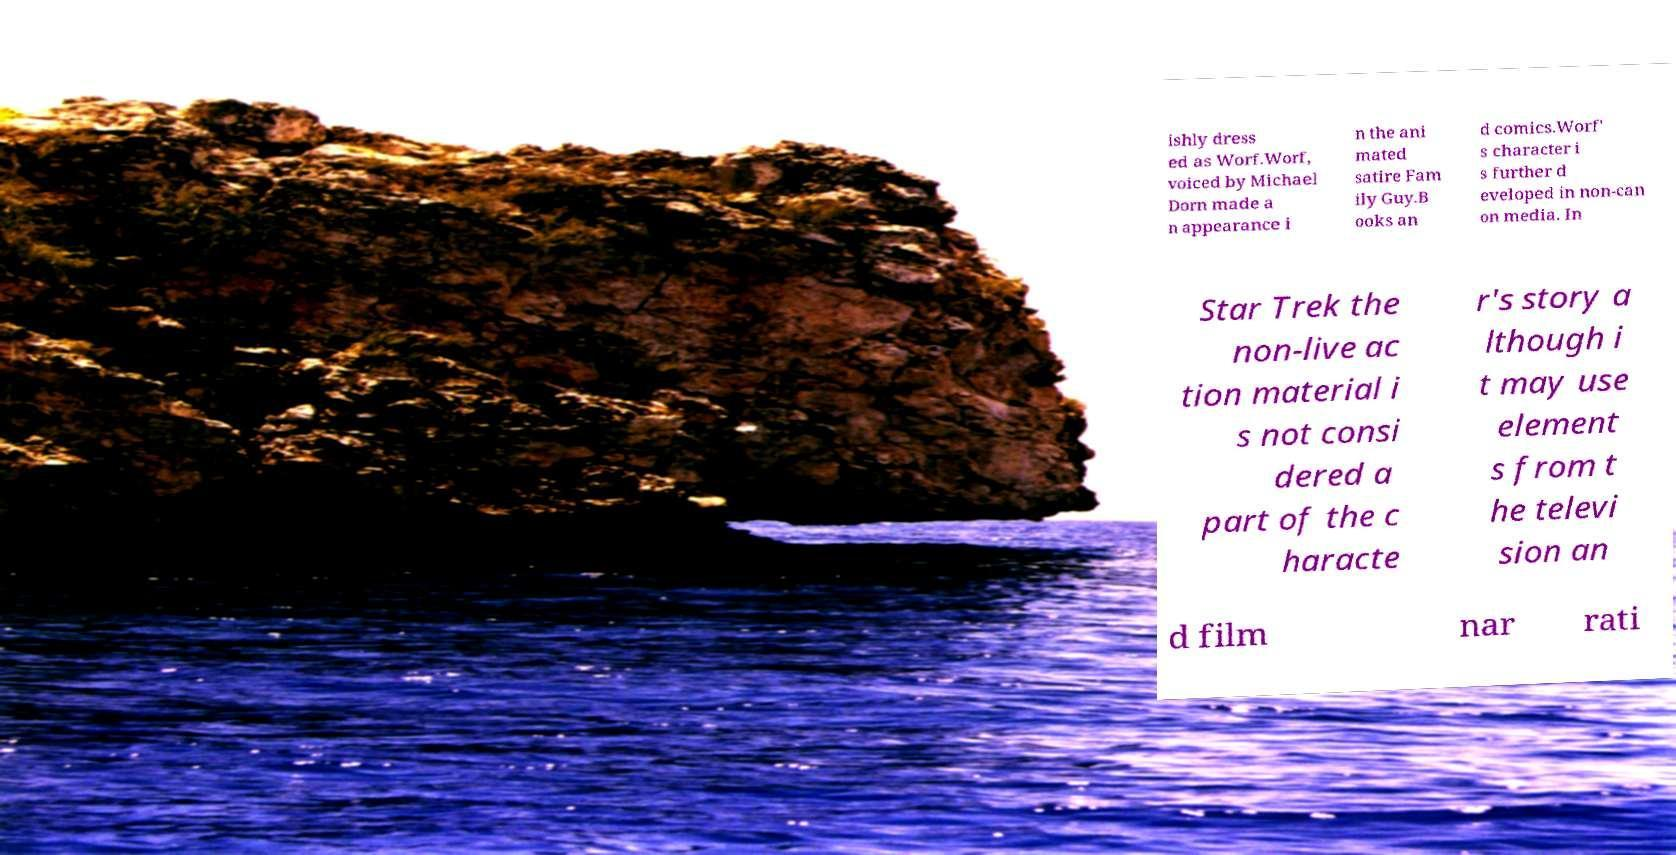Please identify and transcribe the text found in this image. ishly dress ed as Worf.Worf, voiced by Michael Dorn made a n appearance i n the ani mated satire Fam ily Guy.B ooks an d comics.Worf' s character i s further d eveloped in non-can on media. In Star Trek the non-live ac tion material i s not consi dered a part of the c haracte r's story a lthough i t may use element s from t he televi sion an d film nar rati 